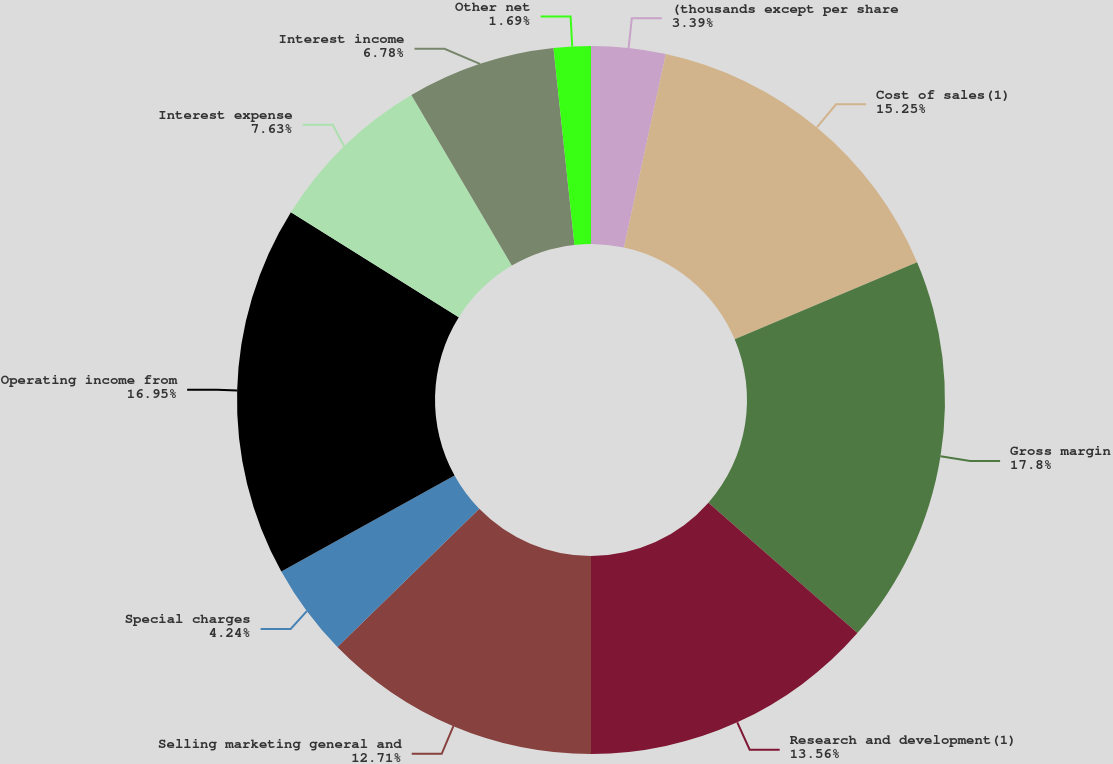Convert chart to OTSL. <chart><loc_0><loc_0><loc_500><loc_500><pie_chart><fcel>(thousands except per share<fcel>Cost of sales(1)<fcel>Gross margin<fcel>Research and development(1)<fcel>Selling marketing general and<fcel>Special charges<fcel>Operating income from<fcel>Interest expense<fcel>Interest income<fcel>Other net<nl><fcel>3.39%<fcel>15.25%<fcel>17.8%<fcel>13.56%<fcel>12.71%<fcel>4.24%<fcel>16.95%<fcel>7.63%<fcel>6.78%<fcel>1.69%<nl></chart> 